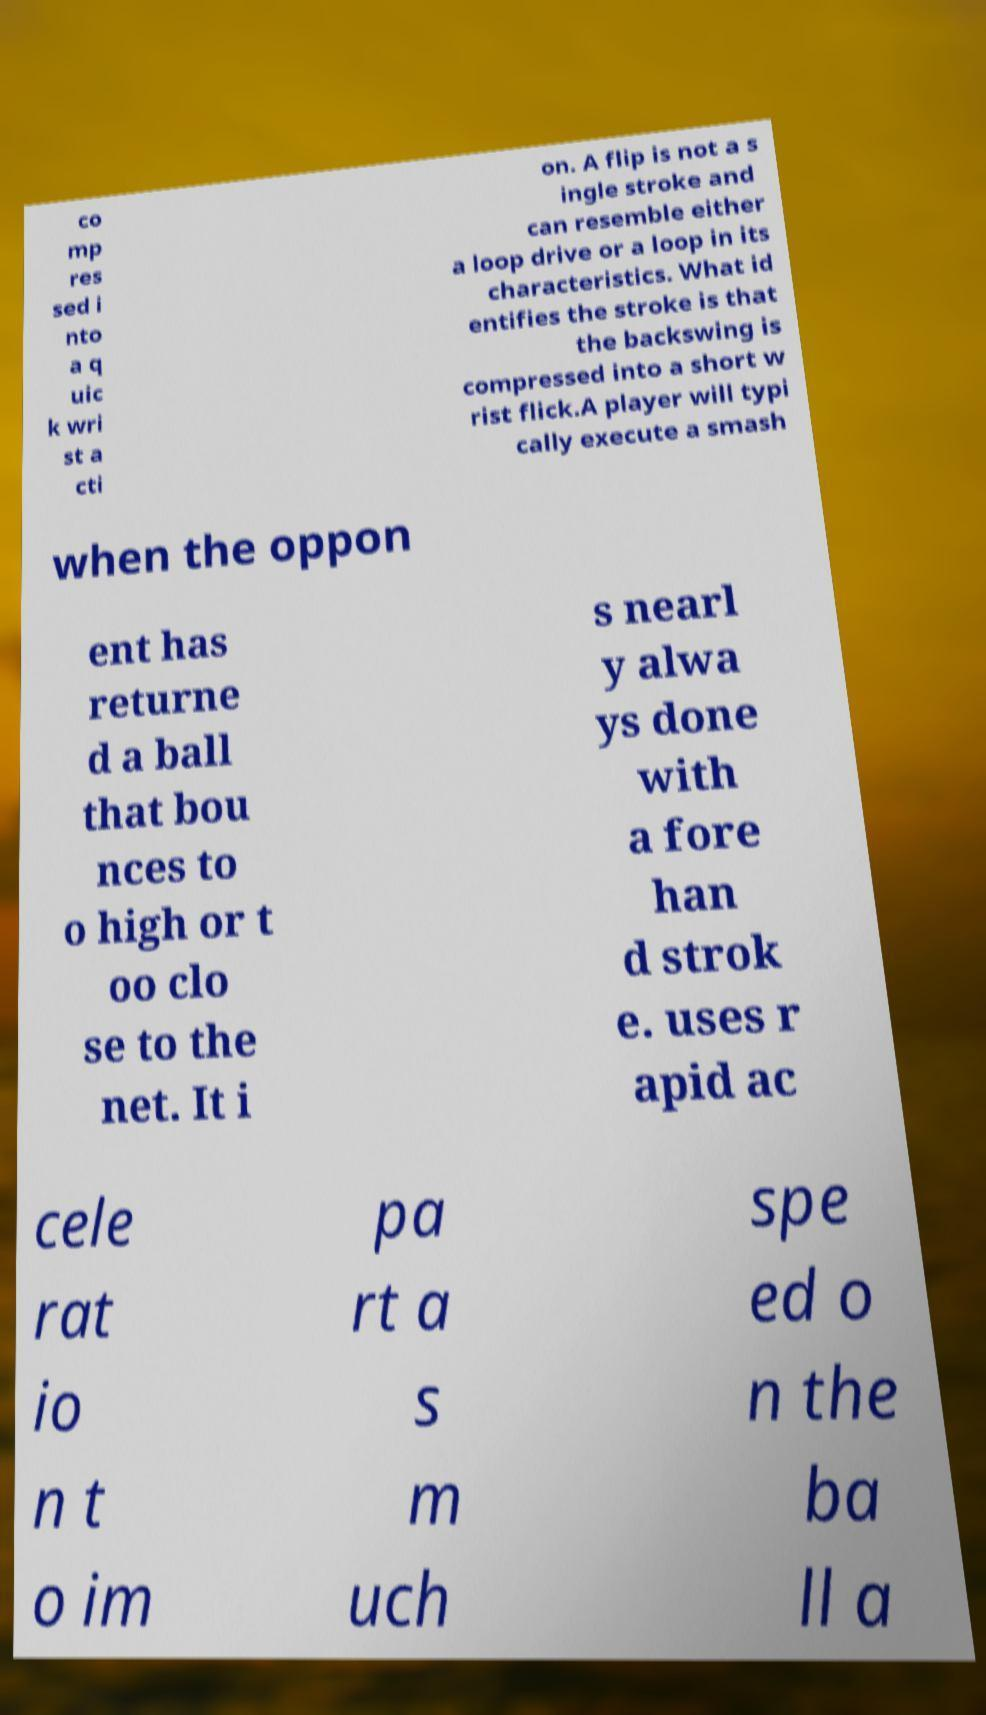Please read and relay the text visible in this image. What does it say? co mp res sed i nto a q uic k wri st a cti on. A flip is not a s ingle stroke and can resemble either a loop drive or a loop in its characteristics. What id entifies the stroke is that the backswing is compressed into a short w rist flick.A player will typi cally execute a smash when the oppon ent has returne d a ball that bou nces to o high or t oo clo se to the net. It i s nearl y alwa ys done with a fore han d strok e. uses r apid ac cele rat io n t o im pa rt a s m uch spe ed o n the ba ll a 